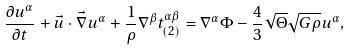<formula> <loc_0><loc_0><loc_500><loc_500>\frac { \partial u ^ { \alpha } } { \partial t } + \vec { u } \cdot \vec { \nabla } u ^ { \alpha } + \frac { 1 } { \rho } \nabla ^ { \beta } t _ { ( 2 ) } ^ { \alpha \beta } = \nabla ^ { \alpha } \Phi - \frac { 4 } { 3 } \sqrt { \Theta } \sqrt { G \rho } u ^ { \alpha } ,</formula> 